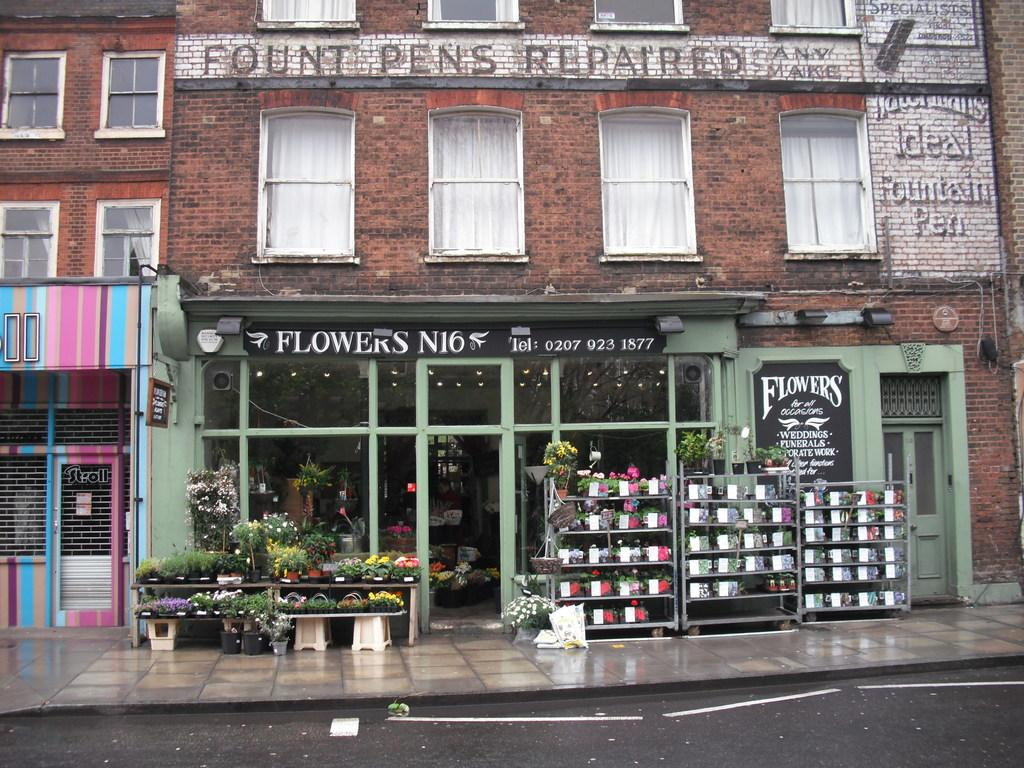<image>
Render a clear and concise summary of the photo. A shop called Flowers N16 in an old building where Fount Pens were repaired. 